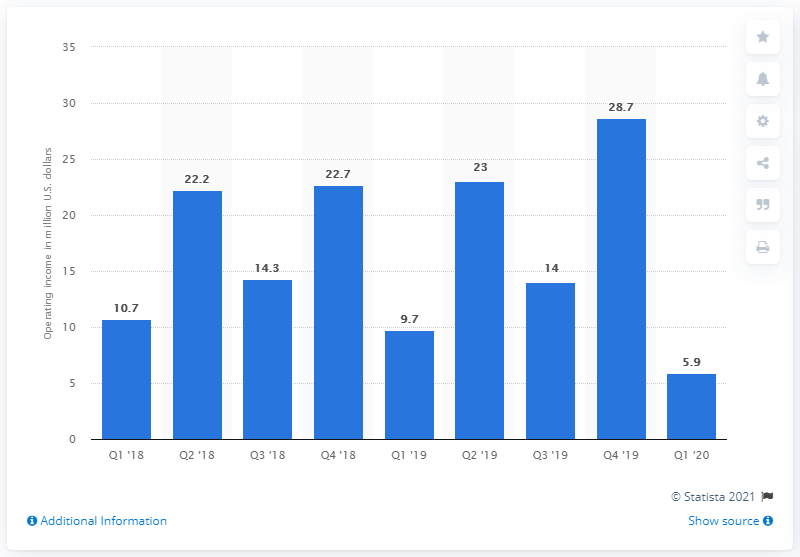What was the operating income of Rakuten Rewards during the last reported period? The operating income of Rakuten Rewards for the last reported period, Q1 '20, was 5.9 million US dollars, according to the bar graph in the image provided. 